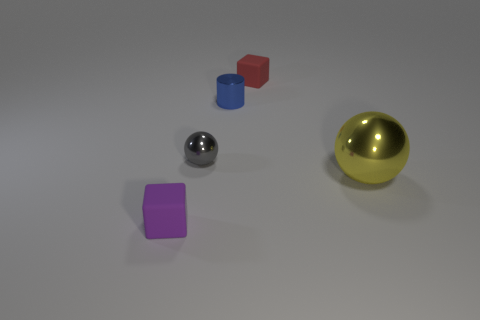How many objects are there and can you describe their shapes and colors? There are four objects in the image, comprising a silver sphere, a yellow sphere, a blue cylinder, and a red cube.  What can you tell me about the lighting and shadows in the scene? The lighting in the scene appears to be coming from the upper side, casting soft shadows directly opposite to each object, suggesting a diffused light source in an indoor setting. 